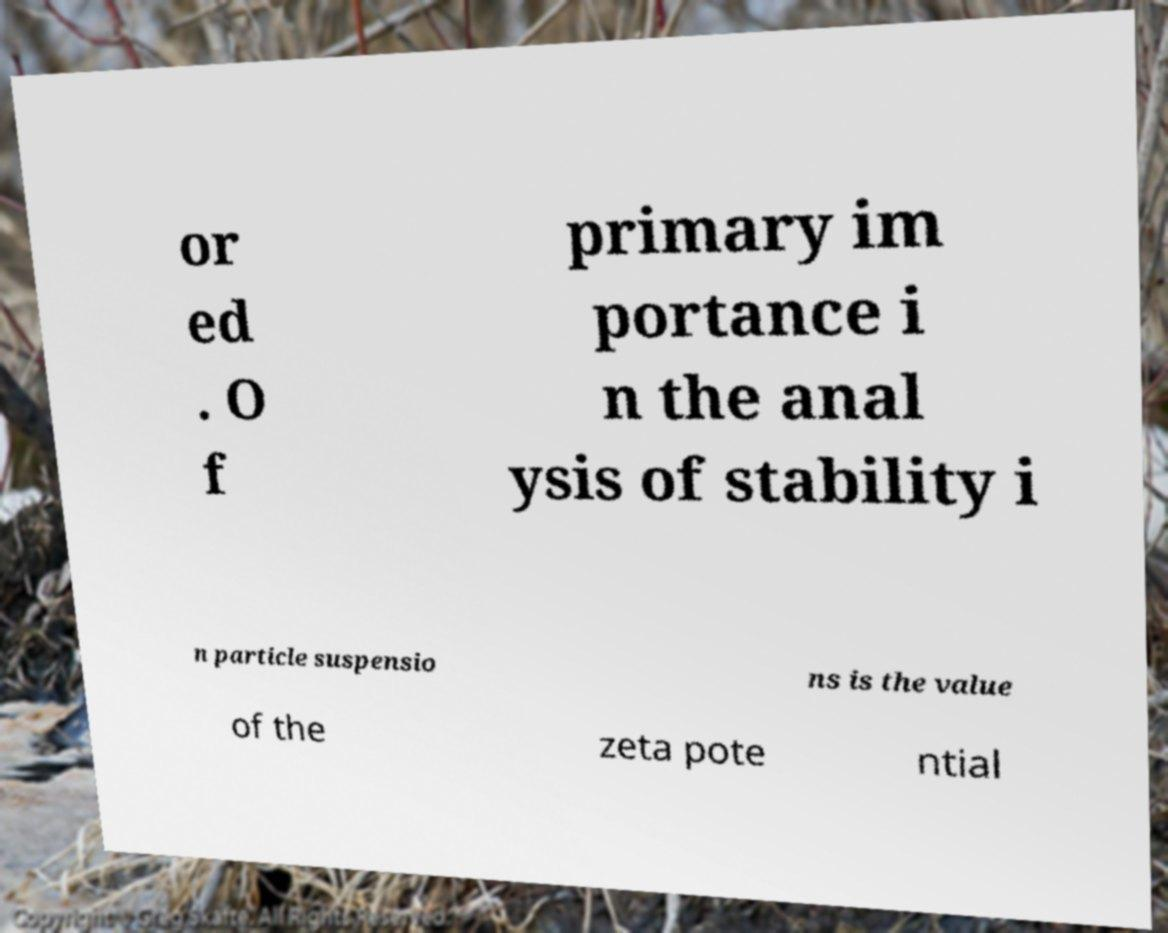Can you accurately transcribe the text from the provided image for me? or ed . O f primary im portance i n the anal ysis of stability i n particle suspensio ns is the value of the zeta pote ntial 